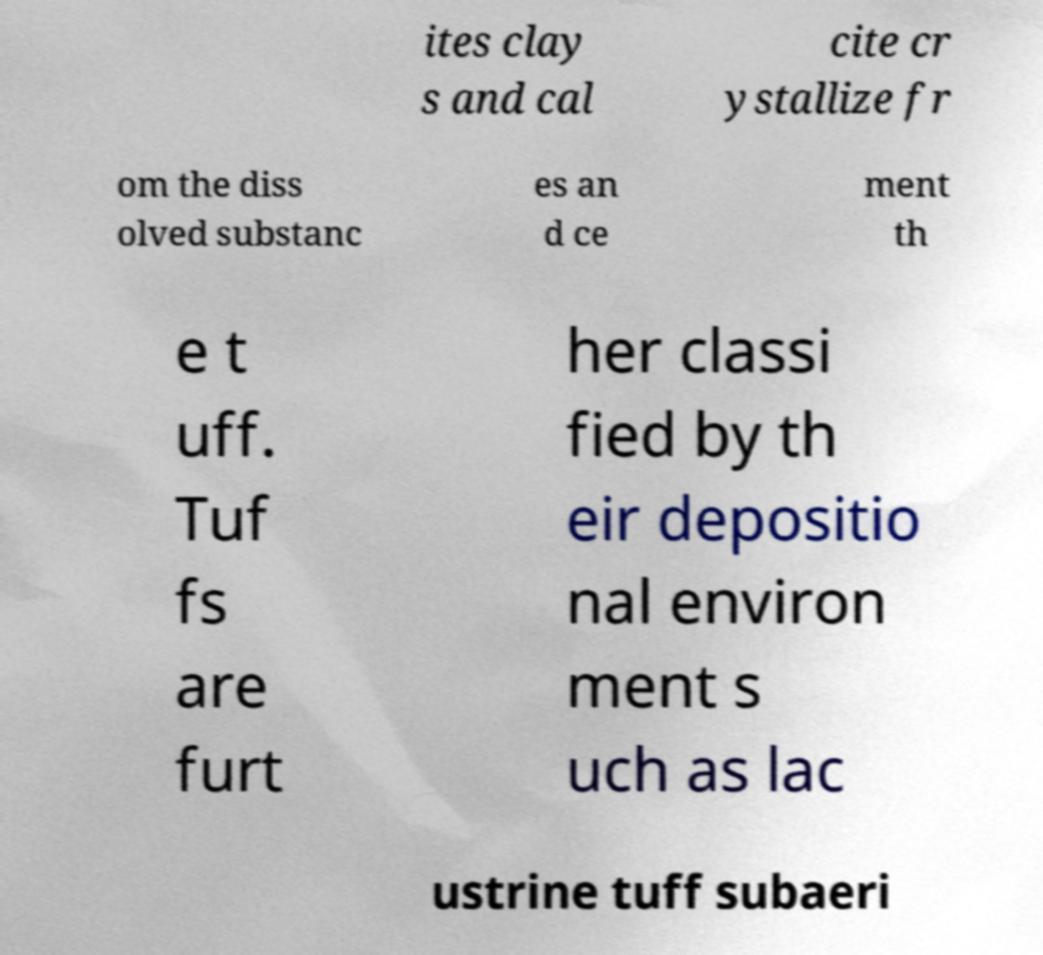Please read and relay the text visible in this image. What does it say? ites clay s and cal cite cr ystallize fr om the diss olved substanc es an d ce ment th e t uff. Tuf fs are furt her classi fied by th eir depositio nal environ ment s uch as lac ustrine tuff subaeri 